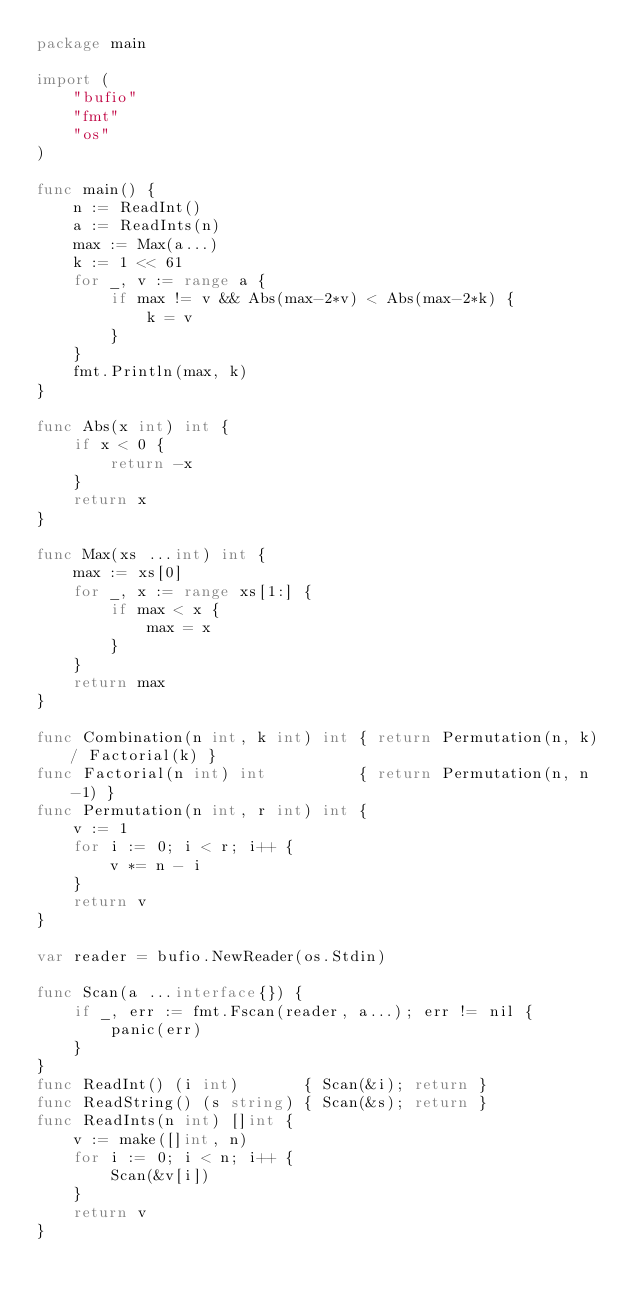Convert code to text. <code><loc_0><loc_0><loc_500><loc_500><_Go_>package main

import (
	"bufio"
	"fmt"
	"os"
)

func main() {
	n := ReadInt()
	a := ReadInts(n)
	max := Max(a...)
	k := 1 << 61
	for _, v := range a {
		if max != v && Abs(max-2*v) < Abs(max-2*k) {
			k = v
		}
	}
	fmt.Println(max, k)
}

func Abs(x int) int {
	if x < 0 {
		return -x
	}
	return x
}

func Max(xs ...int) int {
	max := xs[0]
	for _, x := range xs[1:] {
		if max < x {
			max = x
		}
	}
	return max
}

func Combination(n int, k int) int { return Permutation(n, k) / Factorial(k) }
func Factorial(n int) int          { return Permutation(n, n-1) }
func Permutation(n int, r int) int {
	v := 1
	for i := 0; i < r; i++ {
		v *= n - i
	}
	return v
}

var reader = bufio.NewReader(os.Stdin)

func Scan(a ...interface{}) {
	if _, err := fmt.Fscan(reader, a...); err != nil {
		panic(err)
	}
}
func ReadInt() (i int)       { Scan(&i); return }
func ReadString() (s string) { Scan(&s); return }
func ReadInts(n int) []int {
	v := make([]int, n)
	for i := 0; i < n; i++ {
		Scan(&v[i])
	}
	return v
}
</code> 